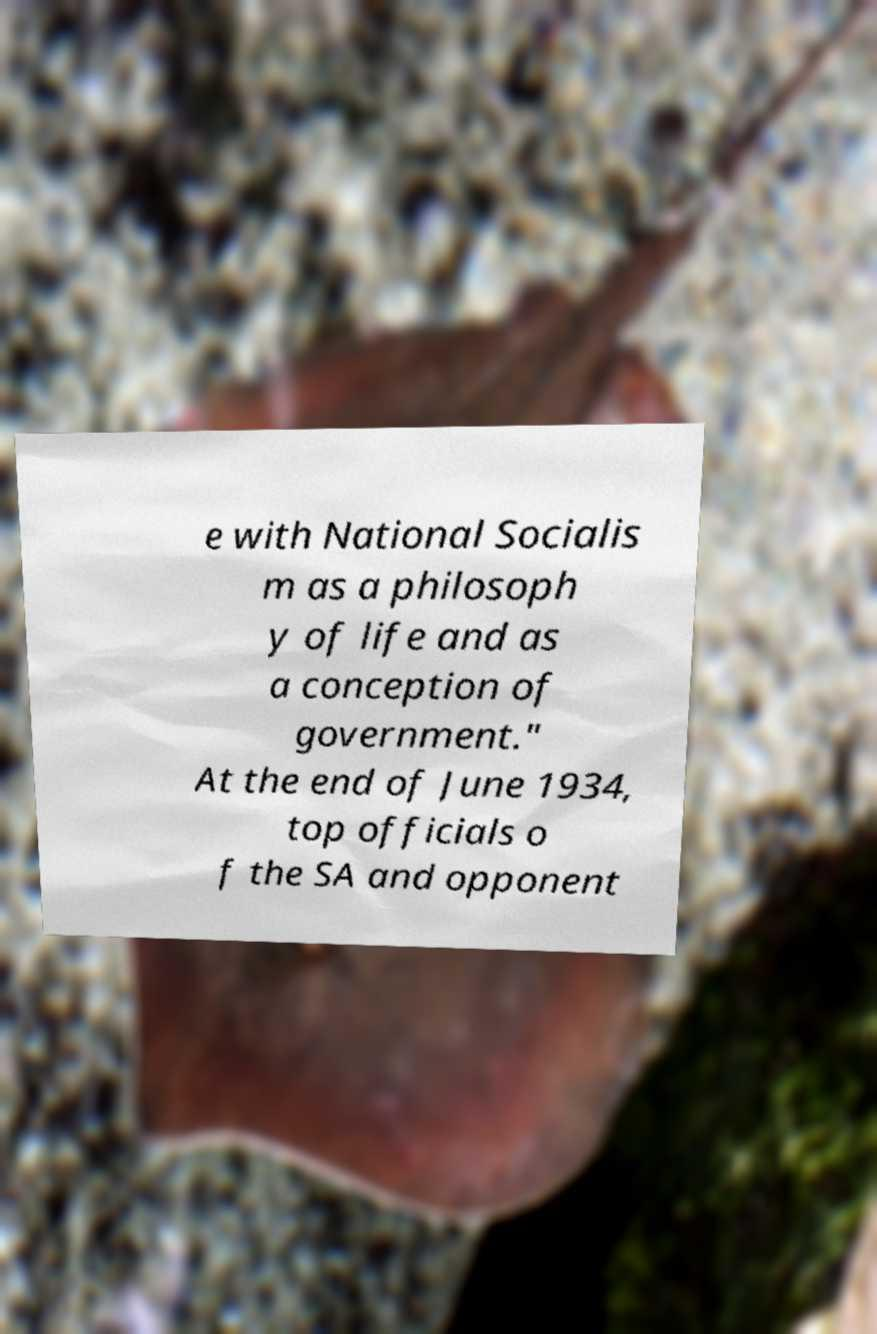Please read and relay the text visible in this image. What does it say? e with National Socialis m as a philosoph y of life and as a conception of government." At the end of June 1934, top officials o f the SA and opponent 